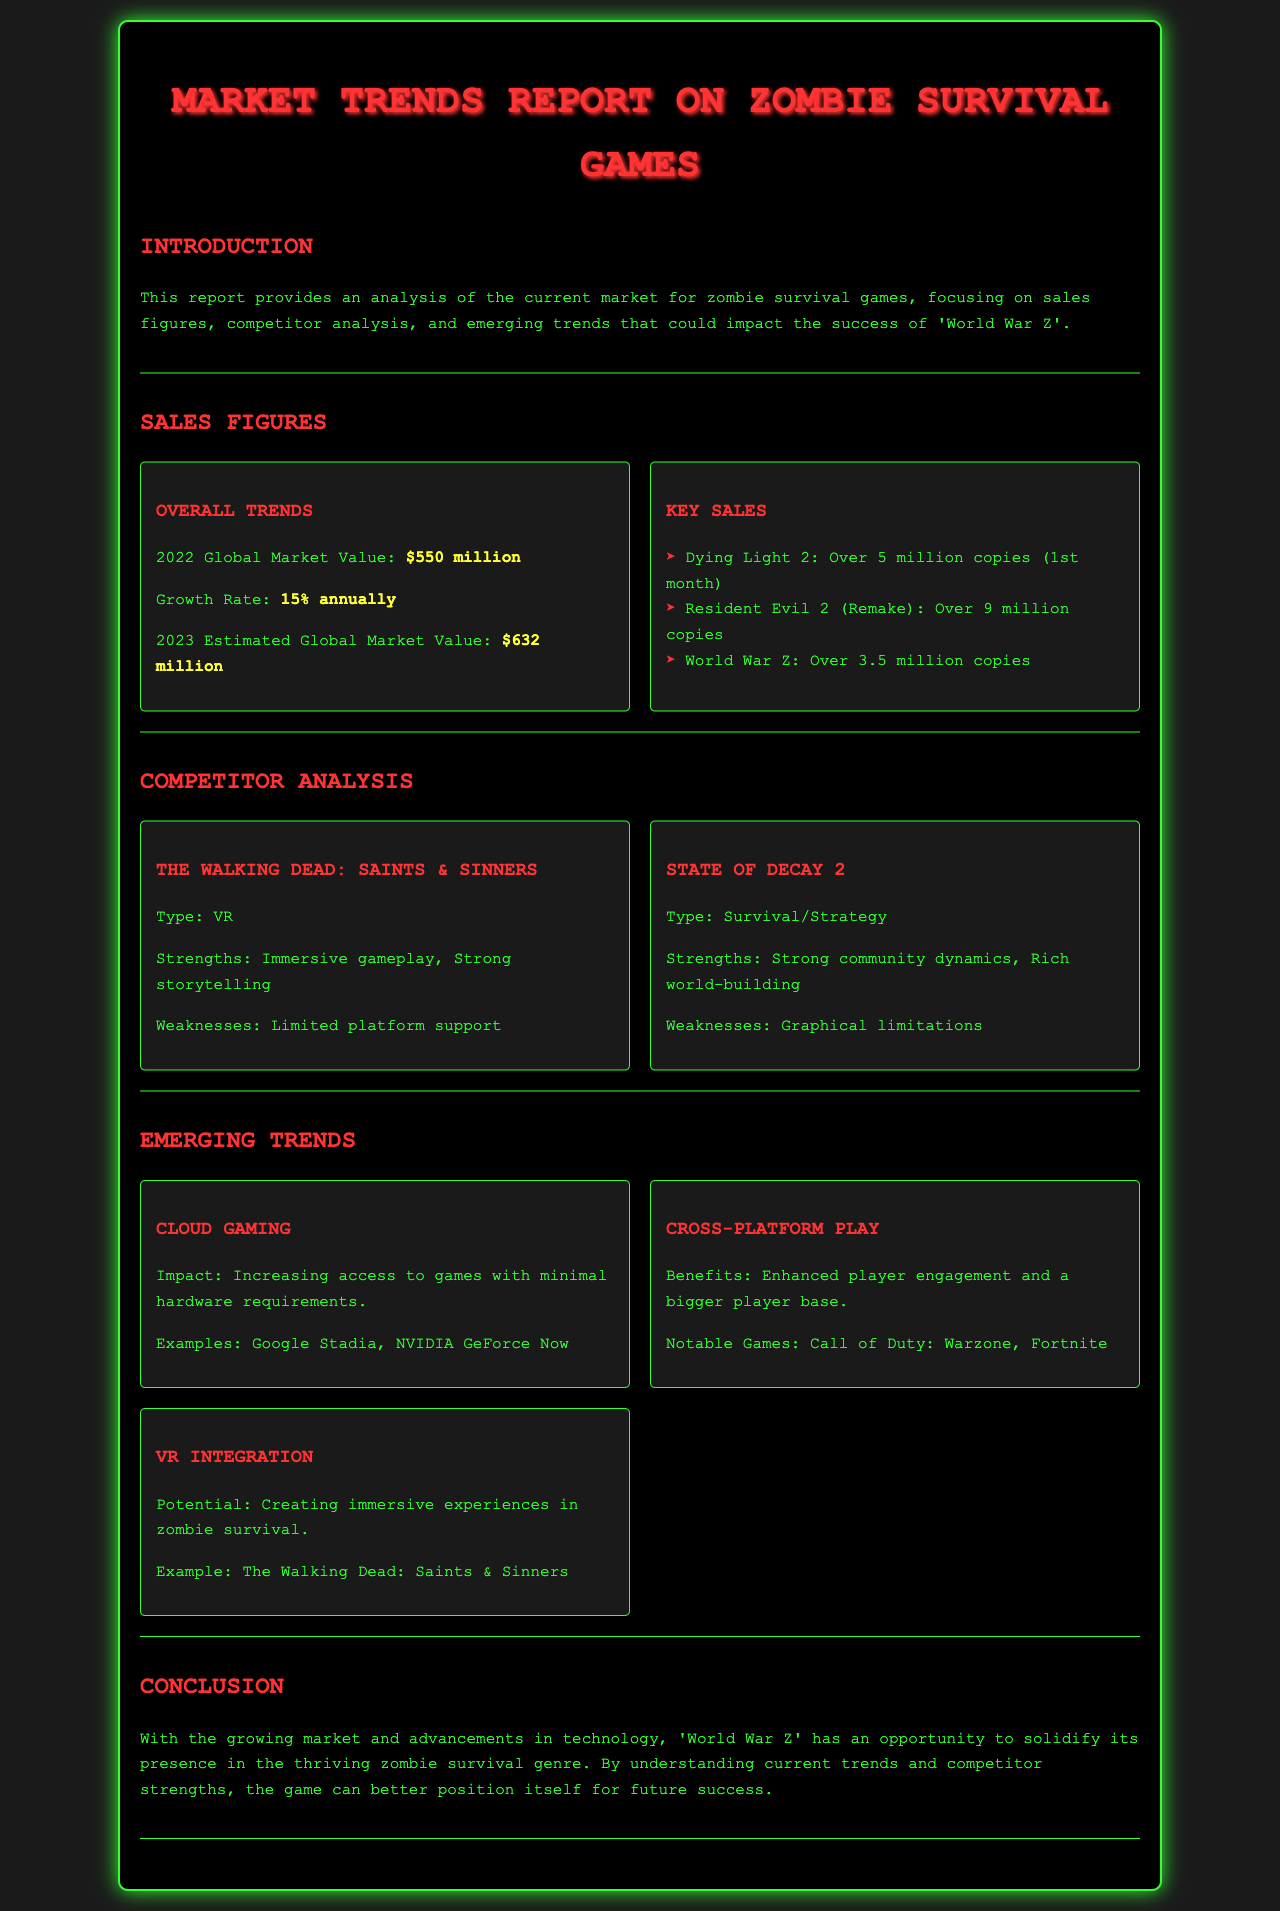What is the global market value for zombie survival games in 2022? The document states that the global market value for 2022 is $550 million.
Answer: $550 million What is the annual growth rate of the zombie survival game market? According to the report, the annual growth rate is 15%.
Answer: 15% How many copies of 'Dying Light 2' were sold in the first month? The report mentions that 'Dying Light 2' sold over 5 million copies in the first month.
Answer: Over 5 million copies Which game has sold over 9 million copies? The document indicates that 'Resident Evil 2 (Remake)' has sold over 9 million copies.
Answer: Resident Evil 2 (Remake) What is one strength of 'The Walking Dead: Saints & Sinners'? The report highlights that an immersive gameplay is a strength of 'The Walking Dead: Saints & Sinners'.
Answer: Immersive gameplay What emerging trend increases access to games with minimal hardware requirements? The report identifies cloud gaming as a trend that increases access to games with minimal hardware requirements.
Answer: Cloud Gaming Which type of gaming allows enhanced player engagement and a bigger player base? The document highlights cross-platform play as a type of gaming that enhances player engagement and a bigger player base.
Answer: Cross-Platform Play What is the potential benefit of VR integration in zombie survival games? The report mentions that VR integration can create immersive experiences in zombie survival.
Answer: Immersive experiences 